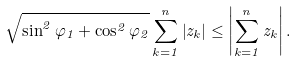Convert formula to latex. <formula><loc_0><loc_0><loc_500><loc_500>\sqrt { \sin ^ { 2 } \varphi _ { 1 } + \cos ^ { 2 } \varphi _ { 2 } } \sum _ { k = 1 } ^ { n } \left | z _ { k } \right | \leq \left | \sum _ { k = 1 } ^ { n } z _ { k } \right | .</formula> 